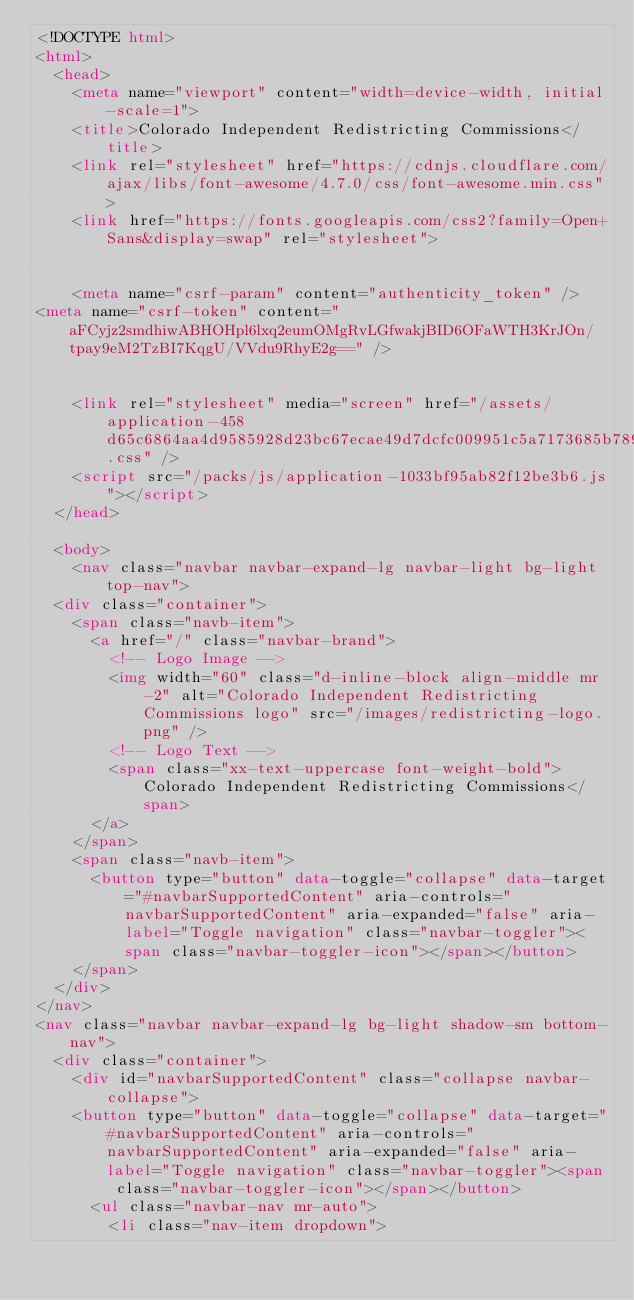Convert code to text. <code><loc_0><loc_0><loc_500><loc_500><_HTML_><!DOCTYPE html>
<html>
  <head>
    <meta name="viewport" content="width=device-width, initial-scale=1">  
    <title>Colorado Independent Redistricting Commissions</title>
    <link rel="stylesheet" href="https://cdnjs.cloudflare.com/ajax/libs/font-awesome/4.7.0/css/font-awesome.min.css">
    <link href="https://fonts.googleapis.com/css2?family=Open+Sans&display=swap" rel="stylesheet">


    <meta name="csrf-param" content="authenticity_token" />
<meta name="csrf-token" content="aFCyjz2smdhiwABHOHpl6lxq2eumOMgRvLGfwakjBID6OFaWTH3KrJOn/tpay9eM2TzBI7KqgU/VVdu9RhyE2g==" />
    

    <link rel="stylesheet" media="screen" href="/assets/application-458d65c6864aa4d9585928d23bc67ecae49d7dcfc009951c5a7173685b789ed3.css" />
    <script src="/packs/js/application-1033bf95ab82f12be3b6.js"></script>
  </head>

  <body>
    <nav class="navbar navbar-expand-lg navbar-light bg-light top-nav">
  <div class="container">
    <span class="navb-item">
      <a href="/" class="navbar-brand">
        <!-- Logo Image -->
        <img width="60" class="d-inline-block align-middle mr-2" alt="Colorado Independent Redistricting Commissions logo" src="/images/redistricting-logo.png" />
        <!-- Logo Text -->
        <span class="xx-text-uppercase font-weight-bold">Colorado Independent Redistricting Commissions</span>
      </a>
    </span>
    <span class="navb-item">
      <button type="button" data-toggle="collapse" data-target="#navbarSupportedContent" aria-controls="navbarSupportedContent" aria-expanded="false" aria-label="Toggle navigation" class="navbar-toggler"><span class="navbar-toggler-icon"></span></button>
    </span>
  </div>
</nav>
<nav class="navbar navbar-expand-lg bg-light shadow-sm bottom-nav">
  <div class="container">
    <div id="navbarSupportedContent" class="collapse navbar-collapse">
    <button type="button" data-toggle="collapse" data-target="#navbarSupportedContent" aria-controls="navbarSupportedContent" aria-expanded="false" aria-label="Toggle navigation" class="navbar-toggler"><span class="navbar-toggler-icon"></span></button>
      <ul class="navbar-nav mr-auto">
        <li class="nav-item dropdown"></code> 